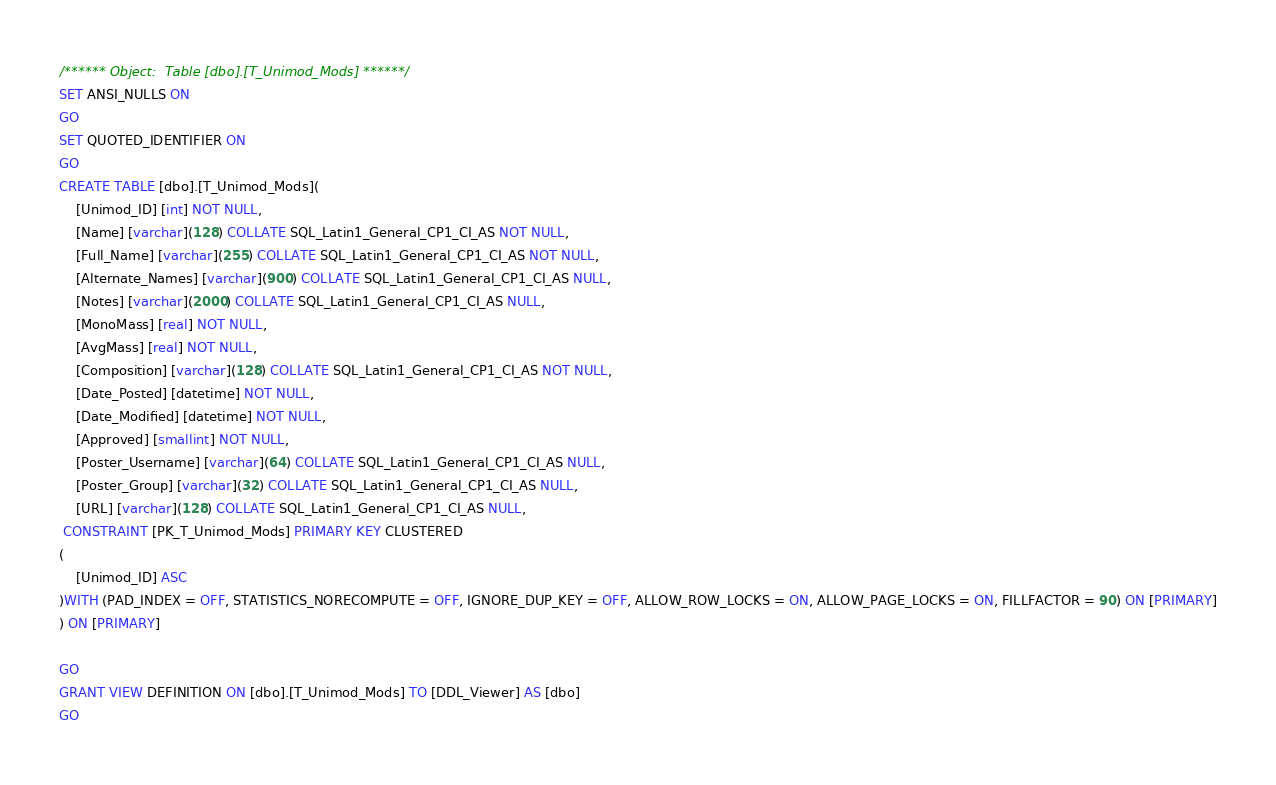<code> <loc_0><loc_0><loc_500><loc_500><_SQL_>/****** Object:  Table [dbo].[T_Unimod_Mods] ******/
SET ANSI_NULLS ON
GO
SET QUOTED_IDENTIFIER ON
GO
CREATE TABLE [dbo].[T_Unimod_Mods](
	[Unimod_ID] [int] NOT NULL,
	[Name] [varchar](128) COLLATE SQL_Latin1_General_CP1_CI_AS NOT NULL,
	[Full_Name] [varchar](255) COLLATE SQL_Latin1_General_CP1_CI_AS NOT NULL,
	[Alternate_Names] [varchar](900) COLLATE SQL_Latin1_General_CP1_CI_AS NULL,
	[Notes] [varchar](2000) COLLATE SQL_Latin1_General_CP1_CI_AS NULL,
	[MonoMass] [real] NOT NULL,
	[AvgMass] [real] NOT NULL,
	[Composition] [varchar](128) COLLATE SQL_Latin1_General_CP1_CI_AS NOT NULL,
	[Date_Posted] [datetime] NOT NULL,
	[Date_Modified] [datetime] NOT NULL,
	[Approved] [smallint] NOT NULL,
	[Poster_Username] [varchar](64) COLLATE SQL_Latin1_General_CP1_CI_AS NULL,
	[Poster_Group] [varchar](32) COLLATE SQL_Latin1_General_CP1_CI_AS NULL,
	[URL] [varchar](128) COLLATE SQL_Latin1_General_CP1_CI_AS NULL,
 CONSTRAINT [PK_T_Unimod_Mods] PRIMARY KEY CLUSTERED 
(
	[Unimod_ID] ASC
)WITH (PAD_INDEX = OFF, STATISTICS_NORECOMPUTE = OFF, IGNORE_DUP_KEY = OFF, ALLOW_ROW_LOCKS = ON, ALLOW_PAGE_LOCKS = ON, FILLFACTOR = 90) ON [PRIMARY]
) ON [PRIMARY]

GO
GRANT VIEW DEFINITION ON [dbo].[T_Unimod_Mods] TO [DDL_Viewer] AS [dbo]
GO
</code> 